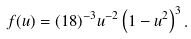<formula> <loc_0><loc_0><loc_500><loc_500>f ( u ) = ( 1 8 ) ^ { - 3 } u ^ { - 2 } \left ( 1 - u ^ { 2 } \right ) ^ { 3 } .</formula> 